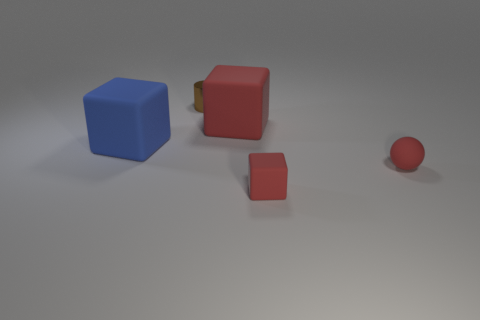Subtract all red cubes. How many cubes are left? 1 Subtract all red cubes. How many cubes are left? 1 Add 2 big blue cubes. How many objects exist? 7 Subtract 1 cylinders. How many cylinders are left? 0 Subtract all spheres. How many objects are left? 4 Subtract all brown balls. Subtract all green blocks. How many balls are left? 1 Subtract all gray cubes. How many blue cylinders are left? 0 Subtract all tiny red rubber blocks. Subtract all shiny cylinders. How many objects are left? 3 Add 1 large red blocks. How many large red blocks are left? 2 Add 5 tiny blue things. How many tiny blue things exist? 5 